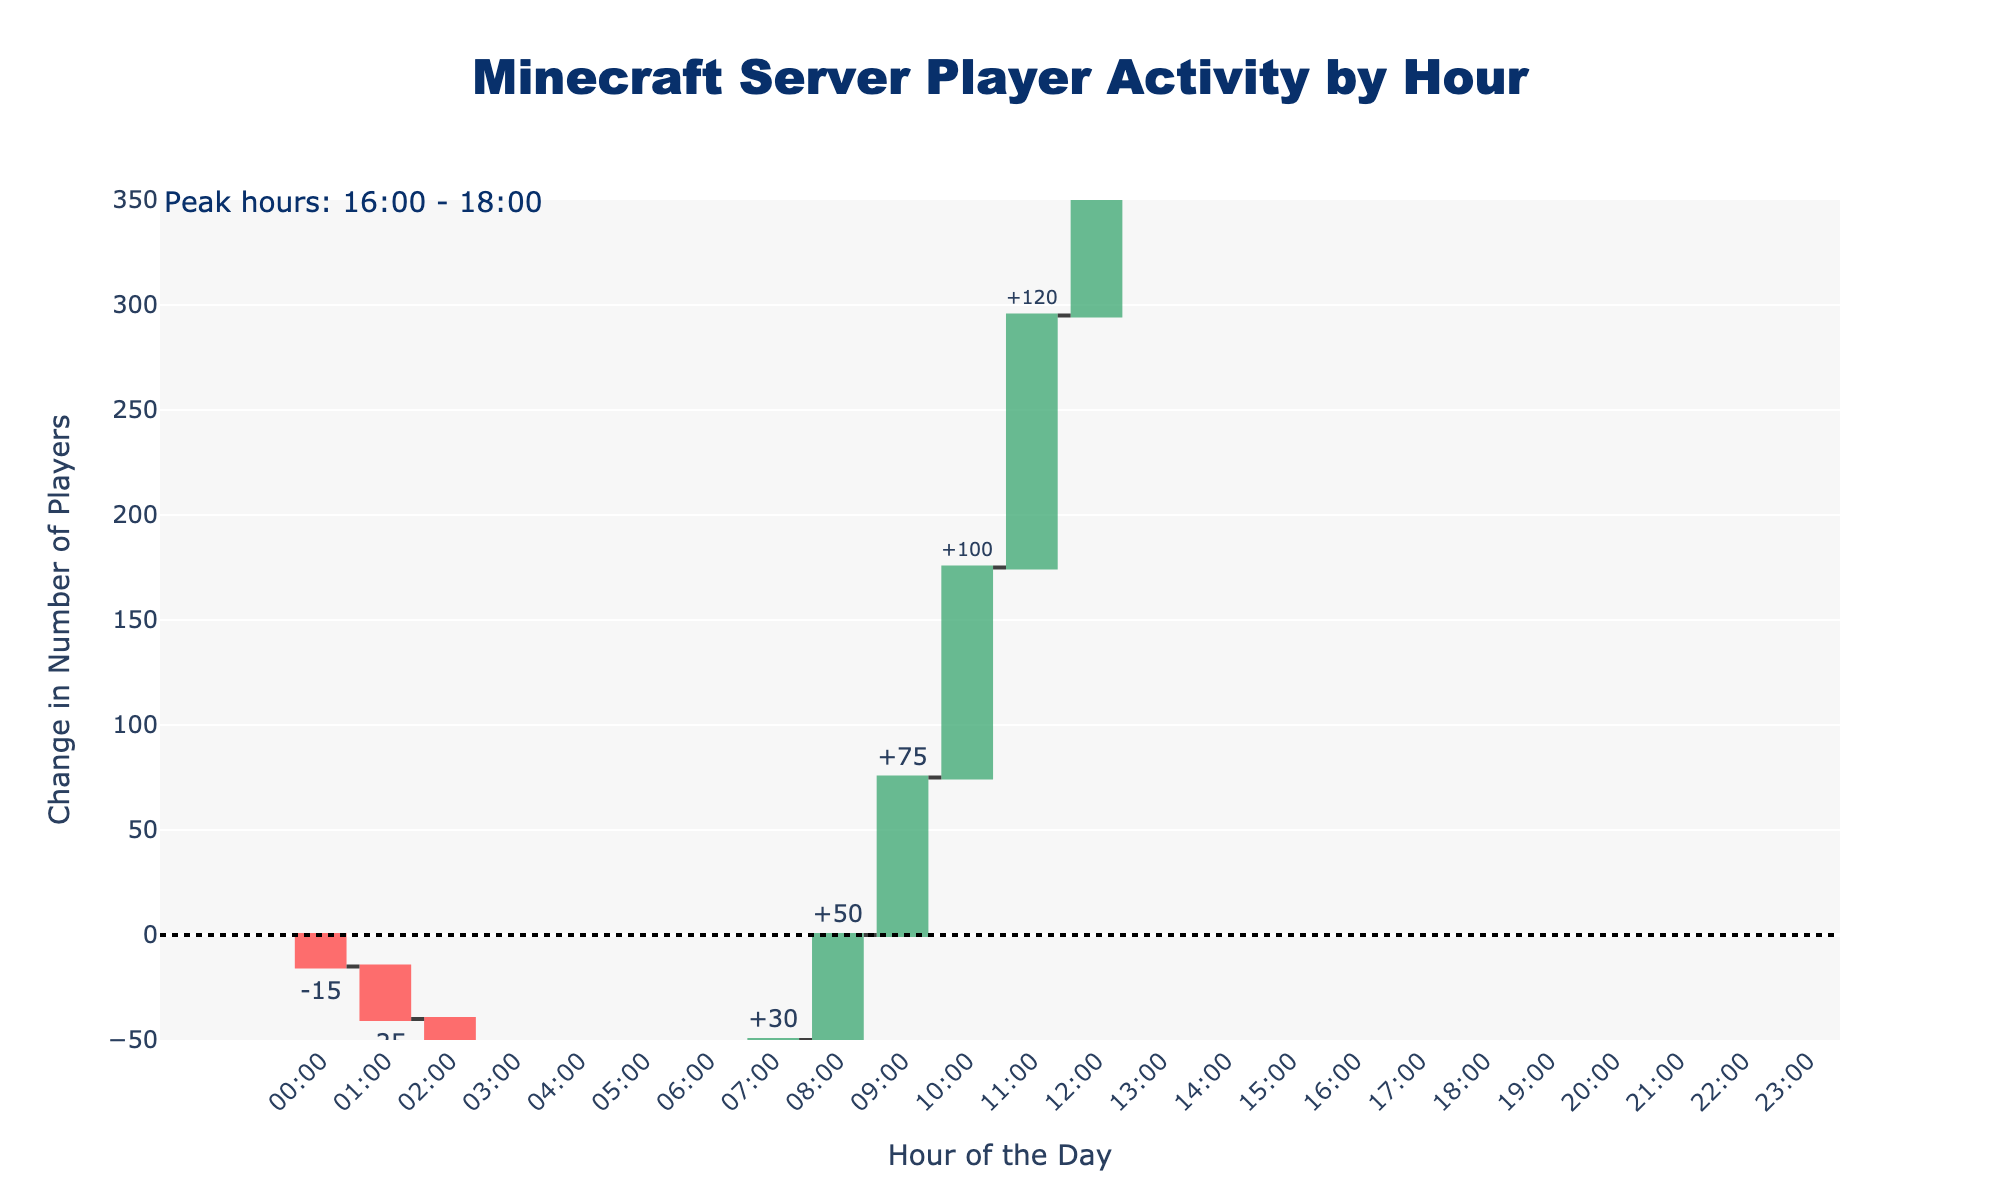what is the title of the chart? The title is displayed at the top center of the chart as "Minecraft Server Player Activity by Hour".
Answer: Minecraft Server Player Activity by Hour how many hours show a negative change in the number of players? To answer this, we count all the bars in the chart that are colored red (indicating a negative change). This occurs in seven hours: 00:00, 01:00, 02:00, 03:00, 04:00, 20:00, and 21:00.
Answer: 7 during which hour is the increase in players the highest? The increase in players is the highest during 18:00, as indicated by the tallest green bar on the chart.
Answer: 18:00 what is the cumulative change in the number of players by 12:00? The cumulative change by 12:00, indicated by summing the changes from 00:00 to 12:00, is 650 players (which is the cumulative value shown at 12:00 on the chart).
Answer: 650 how does the change in players at 20:00 compare to 19:00? The change at 20:00 is -40, while at 19:00 it is +20. The players decreased by 40 at 20:00 compared to an increase of 20 at 19:00, showing a decrease at 20:00.
Answer: decrease what is the total increase in players between 16:00 and 18:00? We add the values of the green bars for 16:00, 17:00, and 18:00. The increases are 250, 280, and 300, respectively. So, 250 + 280 + 300 = 830 players.
Answer: 830 what hours indicate a positive change in players after a series of negative changes? After a series of negative changes (from 00:00 to 04:00), the first hour to show a positive change is 05:00, indicated by a green bar.
Answer: 05:00 what is the color of the bars that represent an increase in the number of players? The bars that represent an increase are colored in green.
Answer: Green which hour shows the least decrease in the number of players? The hour showing the least decrease can be identified by the shortest red bar, which corresponds to 04:00 with a change of -10 players.
Answer: 04:00 how many total hours does the chart cover? The chart covers 24 hours, starting from 00:00 to 23:00.
Answer: 24 